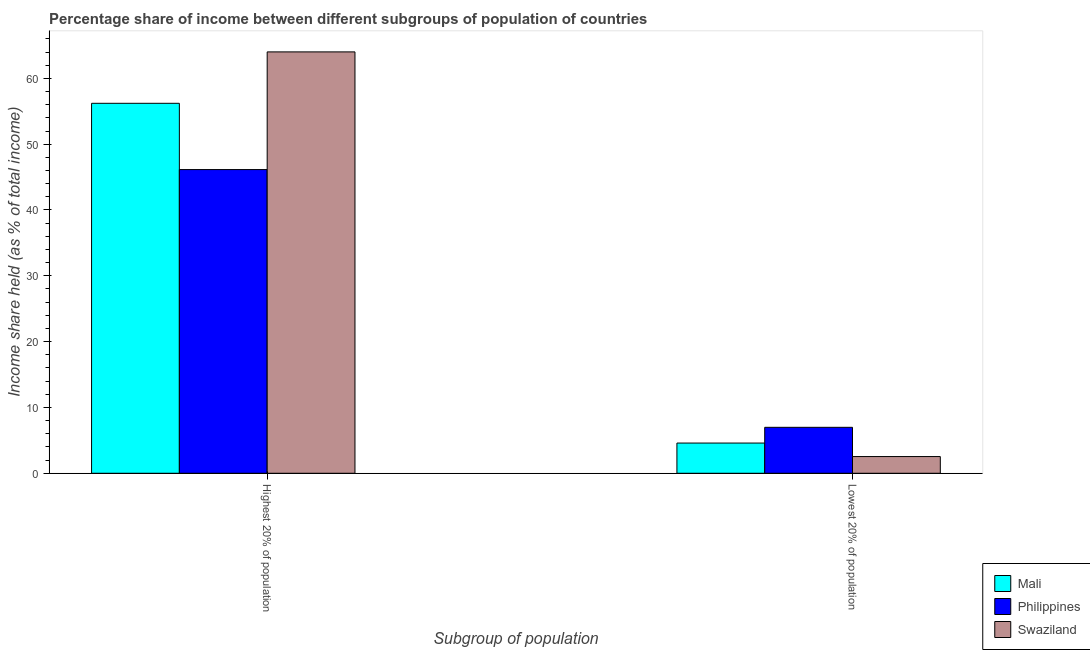How many different coloured bars are there?
Offer a very short reply. 3. Are the number of bars per tick equal to the number of legend labels?
Give a very brief answer. Yes. Are the number of bars on each tick of the X-axis equal?
Provide a short and direct response. Yes. What is the label of the 1st group of bars from the left?
Ensure brevity in your answer.  Highest 20% of population. What is the income share held by highest 20% of the population in Swaziland?
Your answer should be compact. 64.02. Across all countries, what is the maximum income share held by highest 20% of the population?
Provide a short and direct response. 64.02. Across all countries, what is the minimum income share held by highest 20% of the population?
Offer a very short reply. 46.14. In which country was the income share held by highest 20% of the population maximum?
Your answer should be compact. Swaziland. In which country was the income share held by highest 20% of the population minimum?
Offer a terse response. Philippines. What is the total income share held by highest 20% of the population in the graph?
Provide a short and direct response. 166.37. What is the difference between the income share held by lowest 20% of the population in Philippines and that in Swaziland?
Make the answer very short. 4.44. What is the difference between the income share held by highest 20% of the population in Philippines and the income share held by lowest 20% of the population in Swaziland?
Make the answer very short. 43.6. What is the average income share held by highest 20% of the population per country?
Offer a terse response. 55.46. What is the difference between the income share held by highest 20% of the population and income share held by lowest 20% of the population in Swaziland?
Make the answer very short. 61.48. In how many countries, is the income share held by lowest 20% of the population greater than 22 %?
Give a very brief answer. 0. What is the ratio of the income share held by highest 20% of the population in Philippines to that in Mali?
Keep it short and to the point. 0.82. What does the 1st bar from the left in Highest 20% of population represents?
Your answer should be very brief. Mali. What does the 2nd bar from the right in Highest 20% of population represents?
Keep it short and to the point. Philippines. How many bars are there?
Keep it short and to the point. 6. Are all the bars in the graph horizontal?
Make the answer very short. No. Are the values on the major ticks of Y-axis written in scientific E-notation?
Ensure brevity in your answer.  No. Does the graph contain grids?
Make the answer very short. No. How are the legend labels stacked?
Your response must be concise. Vertical. What is the title of the graph?
Your response must be concise. Percentage share of income between different subgroups of population of countries. What is the label or title of the X-axis?
Offer a very short reply. Subgroup of population. What is the label or title of the Y-axis?
Offer a very short reply. Income share held (as % of total income). What is the Income share held (as % of total income) of Mali in Highest 20% of population?
Your answer should be compact. 56.21. What is the Income share held (as % of total income) of Philippines in Highest 20% of population?
Your response must be concise. 46.14. What is the Income share held (as % of total income) of Swaziland in Highest 20% of population?
Your answer should be very brief. 64.02. What is the Income share held (as % of total income) in Mali in Lowest 20% of population?
Ensure brevity in your answer.  4.59. What is the Income share held (as % of total income) of Philippines in Lowest 20% of population?
Keep it short and to the point. 6.98. What is the Income share held (as % of total income) in Swaziland in Lowest 20% of population?
Offer a very short reply. 2.54. Across all Subgroup of population, what is the maximum Income share held (as % of total income) of Mali?
Provide a succinct answer. 56.21. Across all Subgroup of population, what is the maximum Income share held (as % of total income) of Philippines?
Your answer should be very brief. 46.14. Across all Subgroup of population, what is the maximum Income share held (as % of total income) of Swaziland?
Offer a very short reply. 64.02. Across all Subgroup of population, what is the minimum Income share held (as % of total income) in Mali?
Your answer should be very brief. 4.59. Across all Subgroup of population, what is the minimum Income share held (as % of total income) in Philippines?
Make the answer very short. 6.98. Across all Subgroup of population, what is the minimum Income share held (as % of total income) of Swaziland?
Provide a short and direct response. 2.54. What is the total Income share held (as % of total income) in Mali in the graph?
Provide a short and direct response. 60.8. What is the total Income share held (as % of total income) of Philippines in the graph?
Keep it short and to the point. 53.12. What is the total Income share held (as % of total income) in Swaziland in the graph?
Your answer should be compact. 66.56. What is the difference between the Income share held (as % of total income) of Mali in Highest 20% of population and that in Lowest 20% of population?
Give a very brief answer. 51.62. What is the difference between the Income share held (as % of total income) in Philippines in Highest 20% of population and that in Lowest 20% of population?
Offer a terse response. 39.16. What is the difference between the Income share held (as % of total income) in Swaziland in Highest 20% of population and that in Lowest 20% of population?
Offer a very short reply. 61.48. What is the difference between the Income share held (as % of total income) in Mali in Highest 20% of population and the Income share held (as % of total income) in Philippines in Lowest 20% of population?
Your answer should be compact. 49.23. What is the difference between the Income share held (as % of total income) in Mali in Highest 20% of population and the Income share held (as % of total income) in Swaziland in Lowest 20% of population?
Provide a succinct answer. 53.67. What is the difference between the Income share held (as % of total income) of Philippines in Highest 20% of population and the Income share held (as % of total income) of Swaziland in Lowest 20% of population?
Offer a very short reply. 43.6. What is the average Income share held (as % of total income) of Mali per Subgroup of population?
Give a very brief answer. 30.4. What is the average Income share held (as % of total income) in Philippines per Subgroup of population?
Offer a terse response. 26.56. What is the average Income share held (as % of total income) of Swaziland per Subgroup of population?
Offer a terse response. 33.28. What is the difference between the Income share held (as % of total income) of Mali and Income share held (as % of total income) of Philippines in Highest 20% of population?
Your response must be concise. 10.07. What is the difference between the Income share held (as % of total income) of Mali and Income share held (as % of total income) of Swaziland in Highest 20% of population?
Your answer should be very brief. -7.81. What is the difference between the Income share held (as % of total income) of Philippines and Income share held (as % of total income) of Swaziland in Highest 20% of population?
Provide a short and direct response. -17.88. What is the difference between the Income share held (as % of total income) of Mali and Income share held (as % of total income) of Philippines in Lowest 20% of population?
Give a very brief answer. -2.39. What is the difference between the Income share held (as % of total income) of Mali and Income share held (as % of total income) of Swaziland in Lowest 20% of population?
Keep it short and to the point. 2.05. What is the difference between the Income share held (as % of total income) in Philippines and Income share held (as % of total income) in Swaziland in Lowest 20% of population?
Your answer should be compact. 4.44. What is the ratio of the Income share held (as % of total income) in Mali in Highest 20% of population to that in Lowest 20% of population?
Make the answer very short. 12.25. What is the ratio of the Income share held (as % of total income) of Philippines in Highest 20% of population to that in Lowest 20% of population?
Keep it short and to the point. 6.61. What is the ratio of the Income share held (as % of total income) of Swaziland in Highest 20% of population to that in Lowest 20% of population?
Your response must be concise. 25.2. What is the difference between the highest and the second highest Income share held (as % of total income) of Mali?
Give a very brief answer. 51.62. What is the difference between the highest and the second highest Income share held (as % of total income) of Philippines?
Keep it short and to the point. 39.16. What is the difference between the highest and the second highest Income share held (as % of total income) in Swaziland?
Your response must be concise. 61.48. What is the difference between the highest and the lowest Income share held (as % of total income) of Mali?
Your response must be concise. 51.62. What is the difference between the highest and the lowest Income share held (as % of total income) of Philippines?
Give a very brief answer. 39.16. What is the difference between the highest and the lowest Income share held (as % of total income) in Swaziland?
Provide a short and direct response. 61.48. 